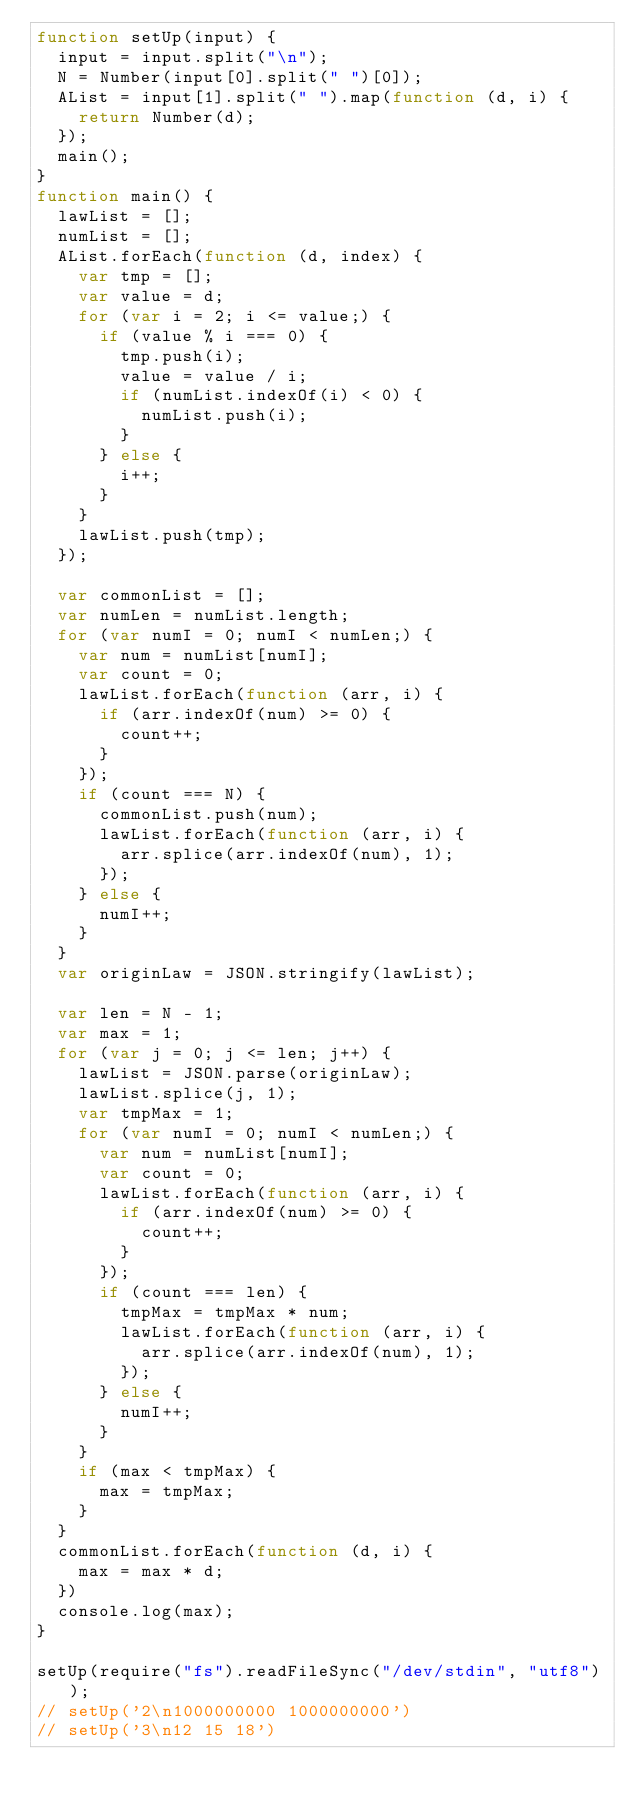<code> <loc_0><loc_0><loc_500><loc_500><_JavaScript_>function setUp(input) {
  input = input.split("\n");
  N = Number(input[0].split(" ")[0]);
  AList = input[1].split(" ").map(function (d, i) {
    return Number(d);
  });
  main();
}
function main() {
  lawList = [];
  numList = [];
  AList.forEach(function (d, index) {
    var tmp = [];
    var value = d;
    for (var i = 2; i <= value;) {
      if (value % i === 0) {
        tmp.push(i);
        value = value / i;
        if (numList.indexOf(i) < 0) {
          numList.push(i);
        }
      } else {
        i++;
      }
    }
    lawList.push(tmp);
  });

  var commonList = [];
  var numLen = numList.length;
  for (var numI = 0; numI < numLen;) {
    var num = numList[numI];
    var count = 0;
    lawList.forEach(function (arr, i) {
      if (arr.indexOf(num) >= 0) {
        count++;
      }
    });
    if (count === N) {
      commonList.push(num);
      lawList.forEach(function (arr, i) {
        arr.splice(arr.indexOf(num), 1);
      });
    } else {
      numI++;
    }
  }
  var originLaw = JSON.stringify(lawList);

  var len = N - 1;
  var max = 1;
  for (var j = 0; j <= len; j++) {
    lawList = JSON.parse(originLaw);
    lawList.splice(j, 1);
    var tmpMax = 1;
    for (var numI = 0; numI < numLen;) {
      var num = numList[numI];
      var count = 0;
      lawList.forEach(function (arr, i) {
        if (arr.indexOf(num) >= 0) {
          count++;
        }
      });
      if (count === len) {
        tmpMax = tmpMax * num;
        lawList.forEach(function (arr, i) {
          arr.splice(arr.indexOf(num), 1);
        });
      } else {
        numI++;
      }
    }
    if (max < tmpMax) {
      max = tmpMax;
    }
  }
  commonList.forEach(function (d, i) {
    max = max * d;
  })
  console.log(max);
}

setUp(require("fs").readFileSync("/dev/stdin", "utf8"));
// setUp('2\n1000000000 1000000000')
// setUp('3\n12 15 18')</code> 